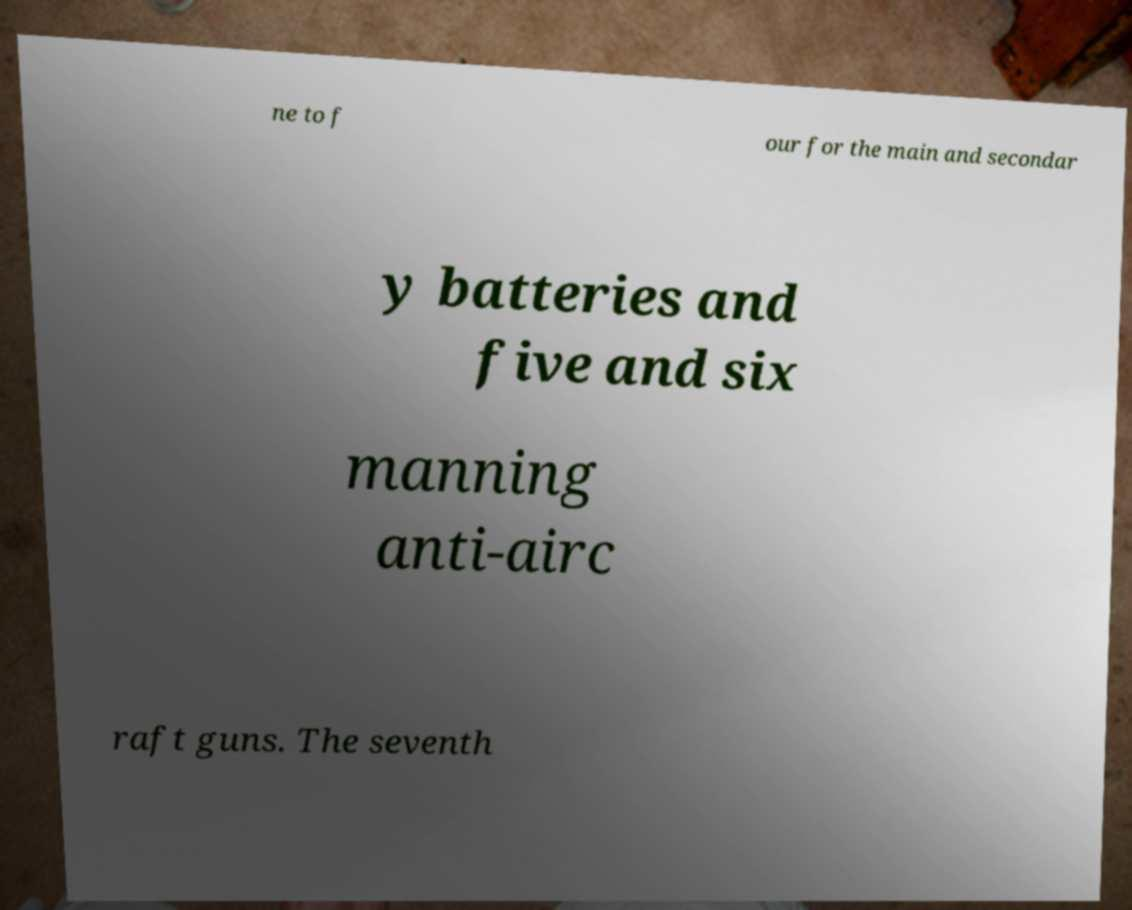I need the written content from this picture converted into text. Can you do that? ne to f our for the main and secondar y batteries and five and six manning anti-airc raft guns. The seventh 